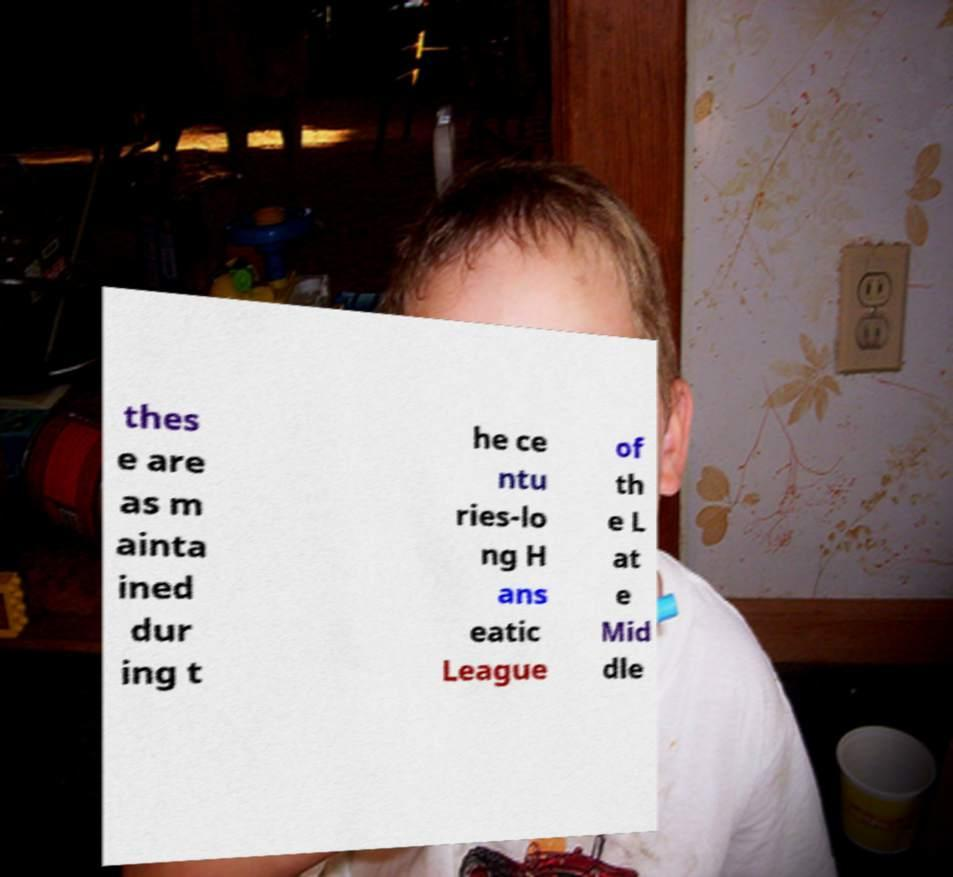What messages or text are displayed in this image? I need them in a readable, typed format. thes e are as m ainta ined dur ing t he ce ntu ries-lo ng H ans eatic League of th e L at e Mid dle 